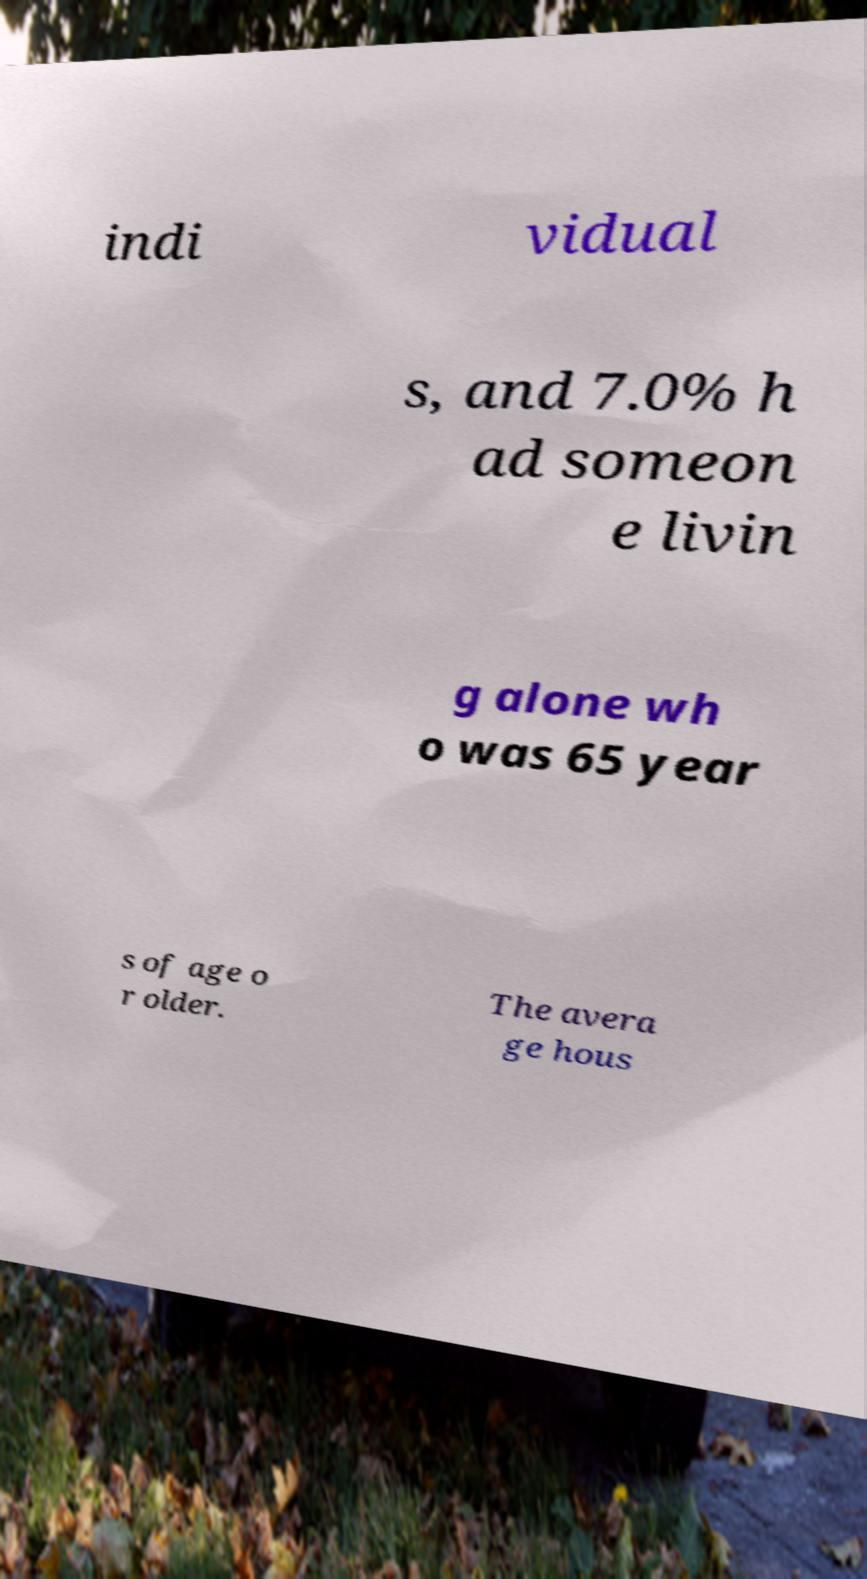What messages or text are displayed in this image? I need them in a readable, typed format. indi vidual s, and 7.0% h ad someon e livin g alone wh o was 65 year s of age o r older. The avera ge hous 